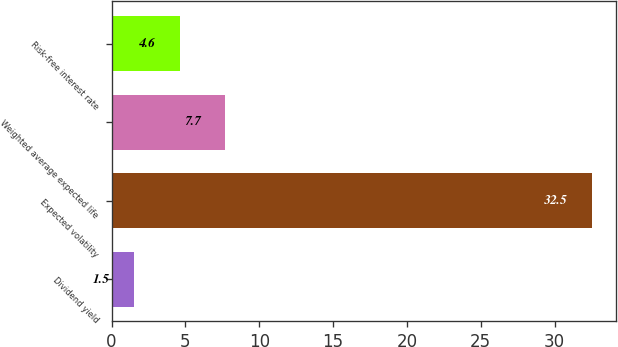Convert chart to OTSL. <chart><loc_0><loc_0><loc_500><loc_500><bar_chart><fcel>Dividend yield<fcel>Expected volatility<fcel>Weighted average expected life<fcel>Risk-free interest rate<nl><fcel>1.5<fcel>32.5<fcel>7.7<fcel>4.6<nl></chart> 